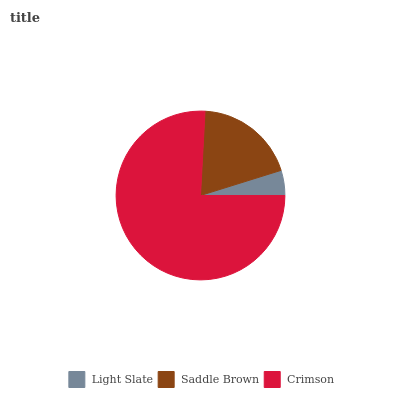Is Light Slate the minimum?
Answer yes or no. Yes. Is Crimson the maximum?
Answer yes or no. Yes. Is Saddle Brown the minimum?
Answer yes or no. No. Is Saddle Brown the maximum?
Answer yes or no. No. Is Saddle Brown greater than Light Slate?
Answer yes or no. Yes. Is Light Slate less than Saddle Brown?
Answer yes or no. Yes. Is Light Slate greater than Saddle Brown?
Answer yes or no. No. Is Saddle Brown less than Light Slate?
Answer yes or no. No. Is Saddle Brown the high median?
Answer yes or no. Yes. Is Saddle Brown the low median?
Answer yes or no. Yes. Is Crimson the high median?
Answer yes or no. No. Is Crimson the low median?
Answer yes or no. No. 